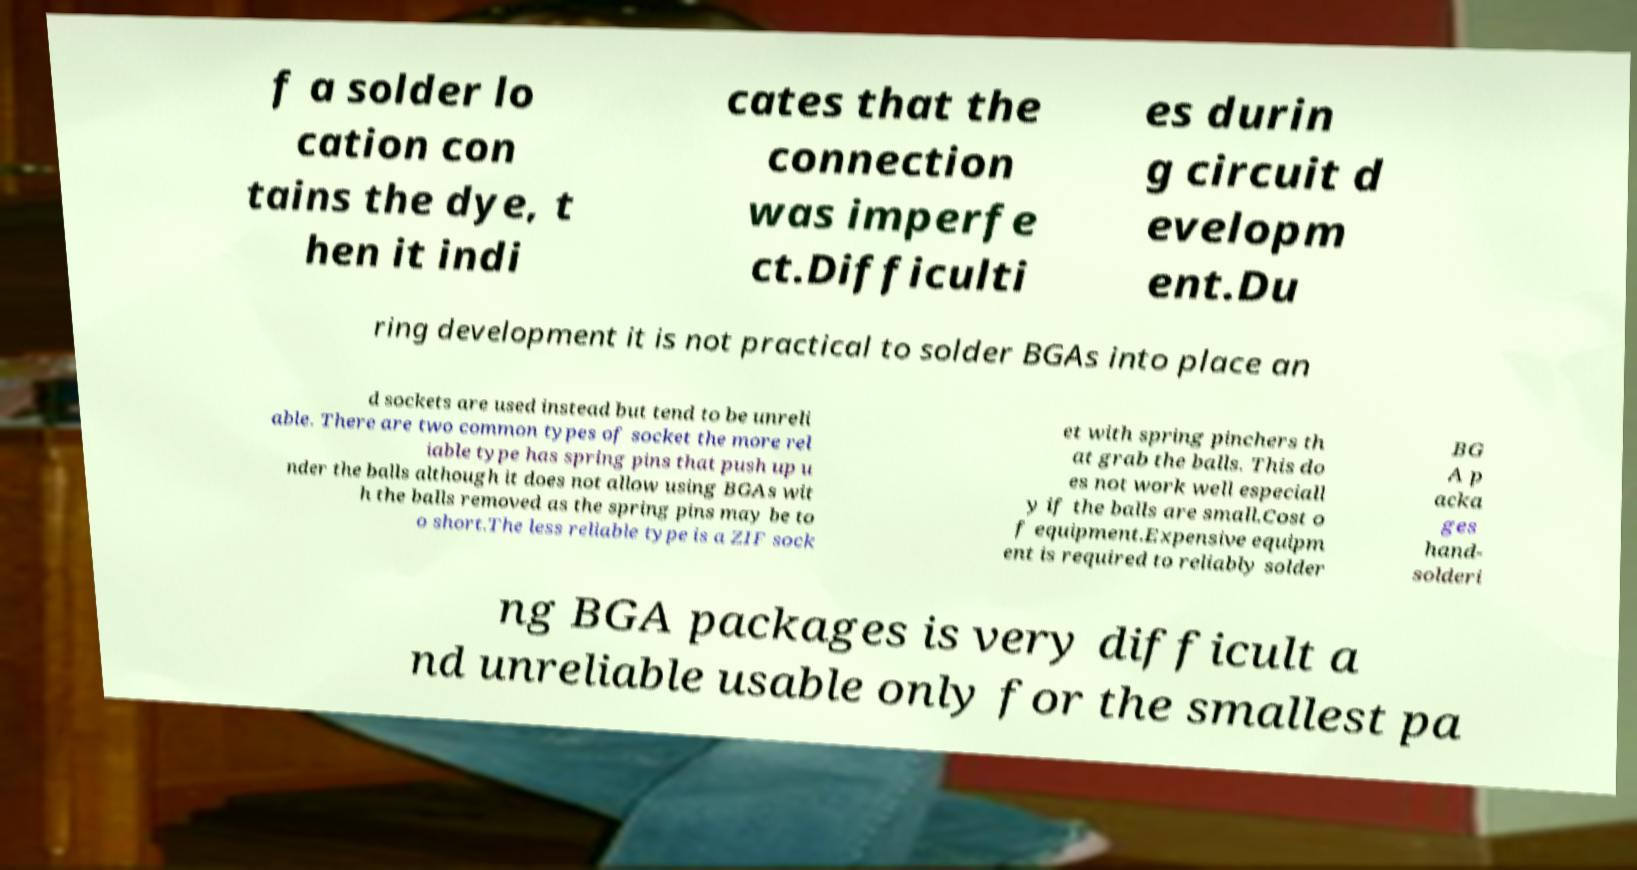Could you extract and type out the text from this image? f a solder lo cation con tains the dye, t hen it indi cates that the connection was imperfe ct.Difficulti es durin g circuit d evelopm ent.Du ring development it is not practical to solder BGAs into place an d sockets are used instead but tend to be unreli able. There are two common types of socket the more rel iable type has spring pins that push up u nder the balls although it does not allow using BGAs wit h the balls removed as the spring pins may be to o short.The less reliable type is a ZIF sock et with spring pinchers th at grab the balls. This do es not work well especiall y if the balls are small.Cost o f equipment.Expensive equipm ent is required to reliably solder BG A p acka ges hand- solderi ng BGA packages is very difficult a nd unreliable usable only for the smallest pa 